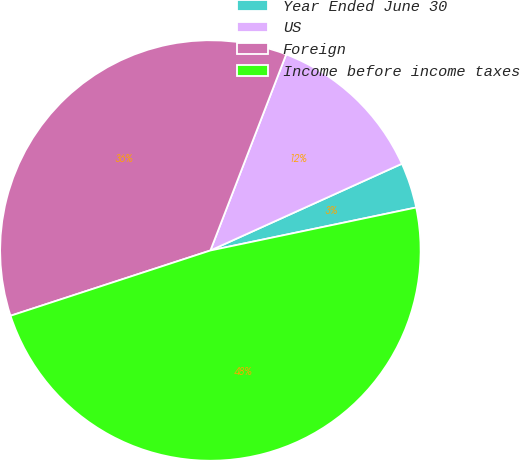<chart> <loc_0><loc_0><loc_500><loc_500><pie_chart><fcel>Year Ended June 30<fcel>US<fcel>Foreign<fcel>Income before income taxes<nl><fcel>3.49%<fcel>12.36%<fcel>35.89%<fcel>48.25%<nl></chart> 